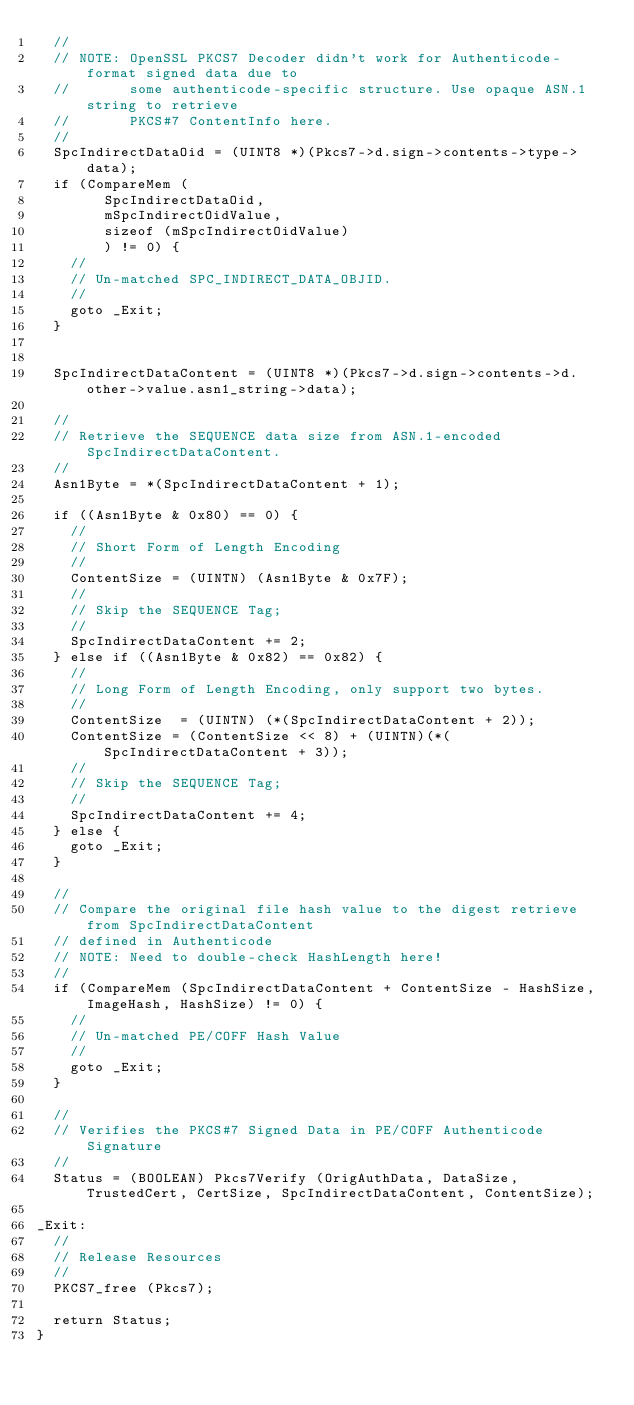Convert code to text. <code><loc_0><loc_0><loc_500><loc_500><_C_>  //
  // NOTE: OpenSSL PKCS7 Decoder didn't work for Authenticode-format signed data due to
  //       some authenticode-specific structure. Use opaque ASN.1 string to retrieve
  //       PKCS#7 ContentInfo here.
  //
  SpcIndirectDataOid = (UINT8 *)(Pkcs7->d.sign->contents->type->data);
  if (CompareMem (
        SpcIndirectDataOid,
        mSpcIndirectOidValue,
        sizeof (mSpcIndirectOidValue)
        ) != 0) {
    //
    // Un-matched SPC_INDIRECT_DATA_OBJID.
    //
    goto _Exit;
  }  


  SpcIndirectDataContent = (UINT8 *)(Pkcs7->d.sign->contents->d.other->value.asn1_string->data);

  //
  // Retrieve the SEQUENCE data size from ASN.1-encoded SpcIndirectDataContent.
  //
  Asn1Byte = *(SpcIndirectDataContent + 1);

  if ((Asn1Byte & 0x80) == 0) {
    //
    // Short Form of Length Encoding
    //
    ContentSize = (UINTN) (Asn1Byte & 0x7F);
    //
    // Skip the SEQUENCE Tag;
    //
    SpcIndirectDataContent += 2;
  } else if ((Asn1Byte & 0x82) == 0x82) {
    //
    // Long Form of Length Encoding, only support two bytes.
    //
    ContentSize  = (UINTN) (*(SpcIndirectDataContent + 2));
    ContentSize = (ContentSize << 8) + (UINTN)(*(SpcIndirectDataContent + 3));
    //
    // Skip the SEQUENCE Tag;
    //
    SpcIndirectDataContent += 4;
  } else {
    goto _Exit;
  }

  //
  // Compare the original file hash value to the digest retrieve from SpcIndirectDataContent
  // defined in Authenticode
  // NOTE: Need to double-check HashLength here!
  //
  if (CompareMem (SpcIndirectDataContent + ContentSize - HashSize, ImageHash, HashSize) != 0) {
    //
    // Un-matched PE/COFF Hash Value
    //
    goto _Exit;
  }

  //
  // Verifies the PKCS#7 Signed Data in PE/COFF Authenticode Signature
  //
  Status = (BOOLEAN) Pkcs7Verify (OrigAuthData, DataSize, TrustedCert, CertSize, SpcIndirectDataContent, ContentSize);

_Exit:
  //
  // Release Resources
  //
  PKCS7_free (Pkcs7);

  return Status;
}
</code> 